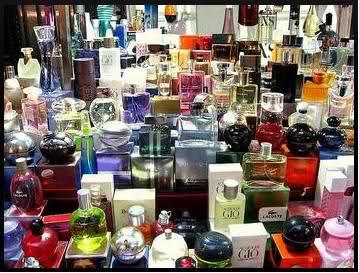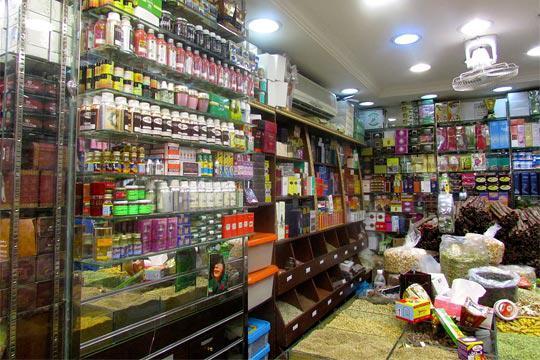The first image is the image on the left, the second image is the image on the right. Evaluate the accuracy of this statement regarding the images: "One of the images shows a corner area of a shop.". Is it true? Answer yes or no. Yes. The first image is the image on the left, the second image is the image on the right. Given the left and right images, does the statement "There are at most four perfume bottles in the left image." hold true? Answer yes or no. No. 